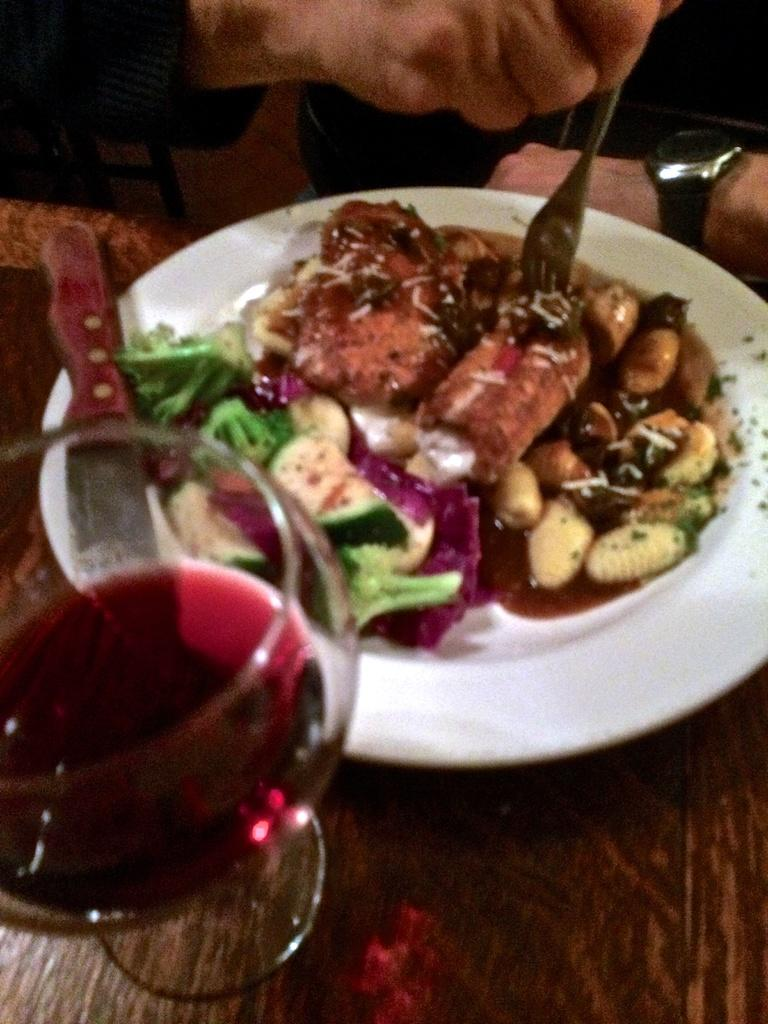What is on the plate that is visible in the image? There is food and a knife on the plate in the image. What else can be seen on the table besides the plate? There is a glass on the table in the image. What is the person holding in the image? The person is holding a fork in the image. Where are all the items located in the image? All items are placed on a table in the image. What type of drum is being played by the person in the image? There is no drum present in the image; the person is holding a fork. What organization is responsible for the arrangement of the items on the table in the image? There is no specific organization mentioned or implied in the image; the items are simply placed on a table. 